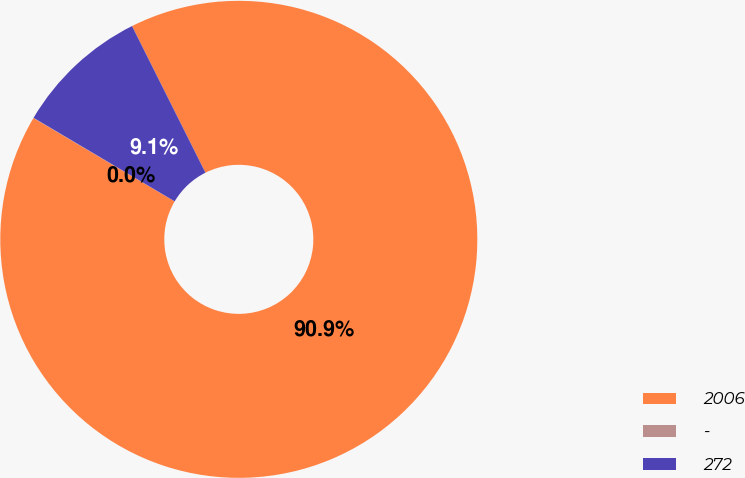Convert chart. <chart><loc_0><loc_0><loc_500><loc_500><pie_chart><fcel>2006<fcel>-<fcel>272<nl><fcel>90.88%<fcel>0.02%<fcel>9.1%<nl></chart> 